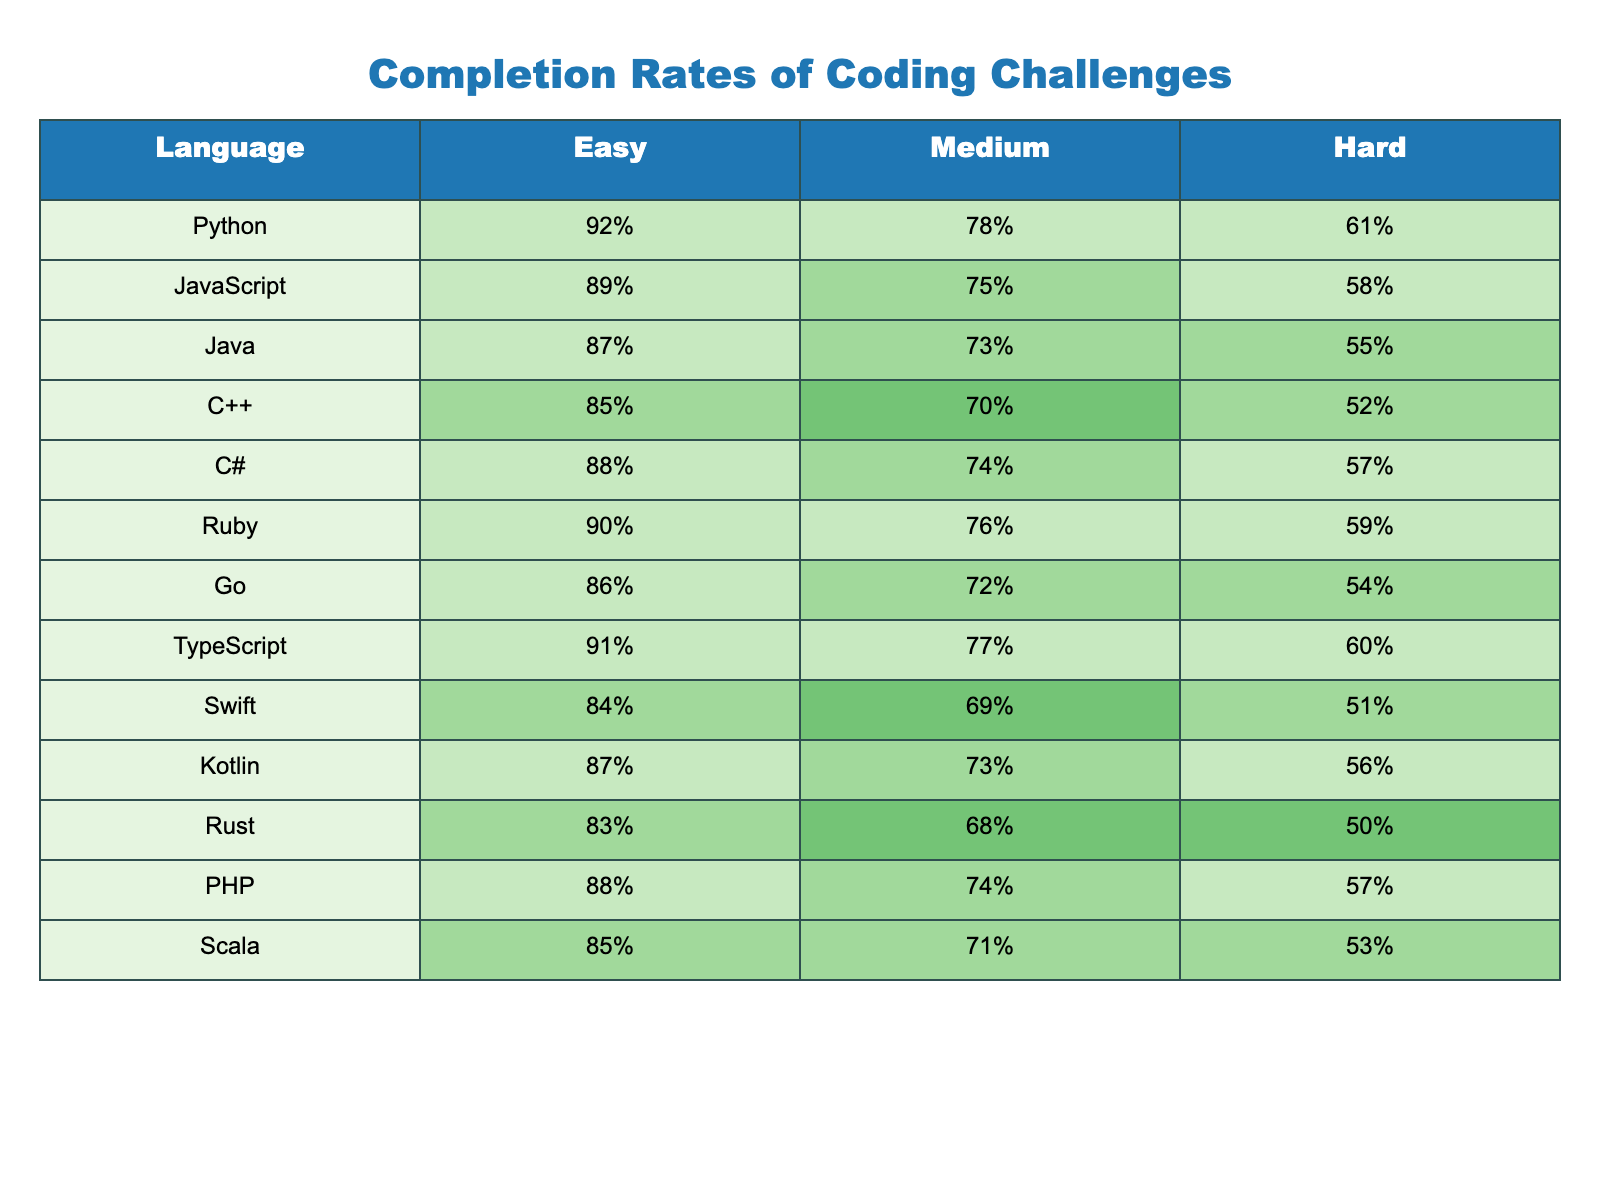What is the completion rate for Python at the 'Easy' difficulty level? The table shows that the 'Easy' completion rate for Python is 92%.
Answer: 92% Which programming language has the lowest completion rate for 'Hard' challenges? By looking at the 'Hard' column, C++ has the lowest completion rate of 52% among the listed languages.
Answer: C++ What is the difference in completion rates between 'Easy' and 'Medium' challenges for JavaScript? The 'Easy' rate for JavaScript is 89%, while the 'Medium' rate is 75%. The difference is 89% - 75% = 14%.
Answer: 14% Which language has a higher completion rate in 'Medium': Ruby or C#? Ruby's completion rate for 'Medium' is 76%, and C#'s is 74%. Since 76% > 74%, Ruby has the higher rate.
Answer: Ruby What is the average completion rate for 'Medium' challenges across all languages provided? Summing the 'Medium' rates: 78 + 75 + 73 + 70 + 74 + 76 + 72 + 77 + 69 + 73 + 68 + 74 + 71 = 886%. There are 13 languages, so the average is 886% / 13 ≈ 68.92%.
Answer: 68.92% Is the completion rate for 'Hard' challenges in Rust above or below 55%? Rust has a 'Hard' completion rate of 50%, which is below 55%.
Answer: Below Which programming languages have 'Easy' rates above 90%? By examining the 'Easy' column, the languages with rates above 90% are Python (92%) and Ruby (90%).
Answer: Python, Ruby If you were to rank the languages by their 'Hard' completion rates from highest to lowest, what would the top three be? The 'Hard' rates in descending order are: PHP (57%), C# (57%), Ruby (59%). Thus, the top three are Ruby, PHP, C#.
Answer: Ruby, PHP, C# How many languages have completion rates of at least 85% for 'Easy' challenges? The languages with 'Easy' rates of at least 85% are Python, JavaScript, Ruby, TypeScript, and C#, making a total of 5 languages.
Answer: 5 What is the completion rate for Kotlin at the 'Hard' difficulty level? According to the table, Kotlin has a 'Hard' completion rate of 56%.
Answer: 56% Is the 'Medium' completion rate for Go higher than that for C++? Go has a 'Medium' completion rate of 72%, while C++ has 70%. Since 72% > 70%, it is higher.
Answer: Yes 